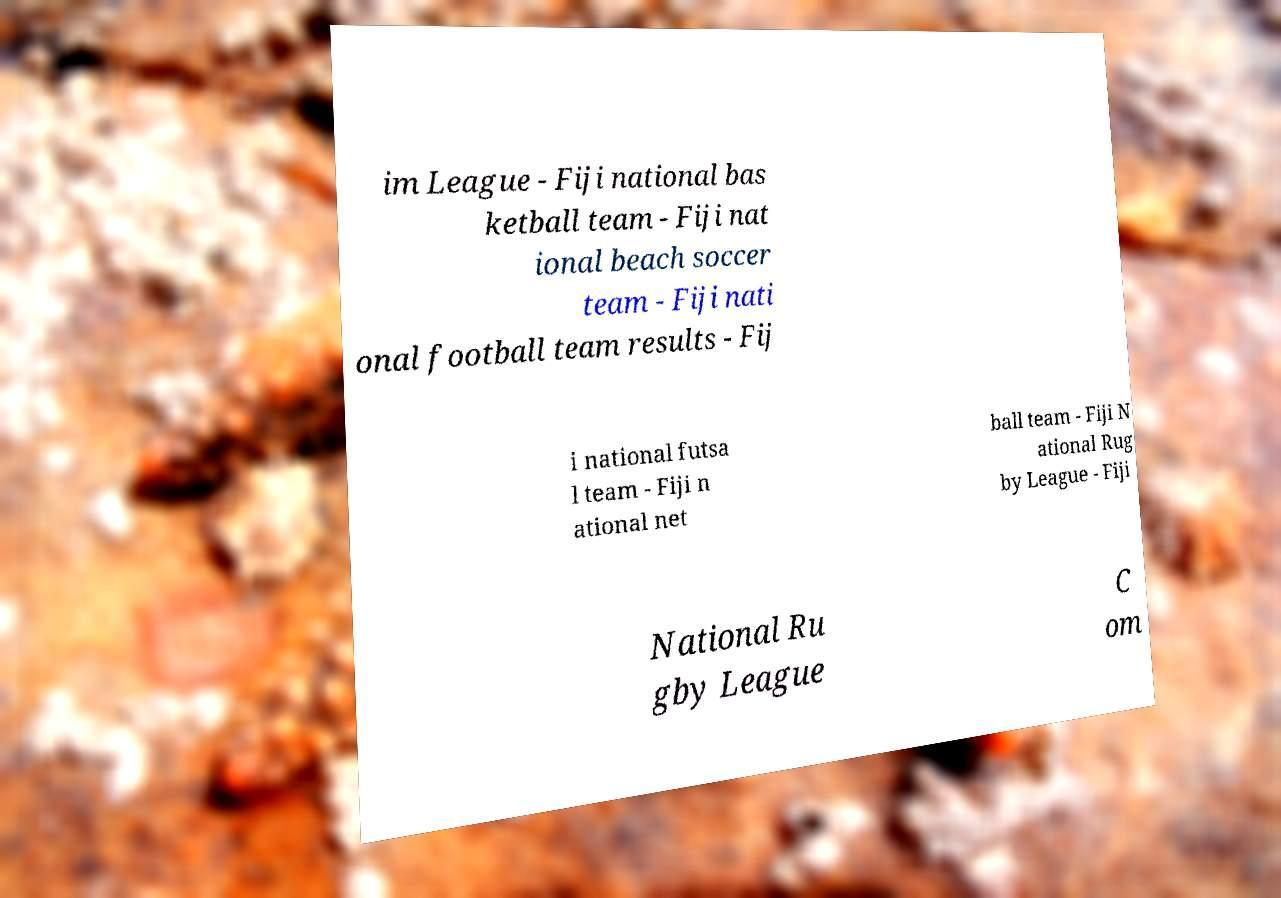For documentation purposes, I need the text within this image transcribed. Could you provide that? im League - Fiji national bas ketball team - Fiji nat ional beach soccer team - Fiji nati onal football team results - Fij i national futsa l team - Fiji n ational net ball team - Fiji N ational Rug by League - Fiji National Ru gby League C om 